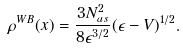Convert formula to latex. <formula><loc_0><loc_0><loc_500><loc_500>\rho ^ { W B } ( x ) = \frac { 3 N _ { a s } ^ { 2 } } { 8 \epsilon ^ { 3 / 2 } } ( \epsilon - V ) ^ { 1 / 2 } .</formula> 